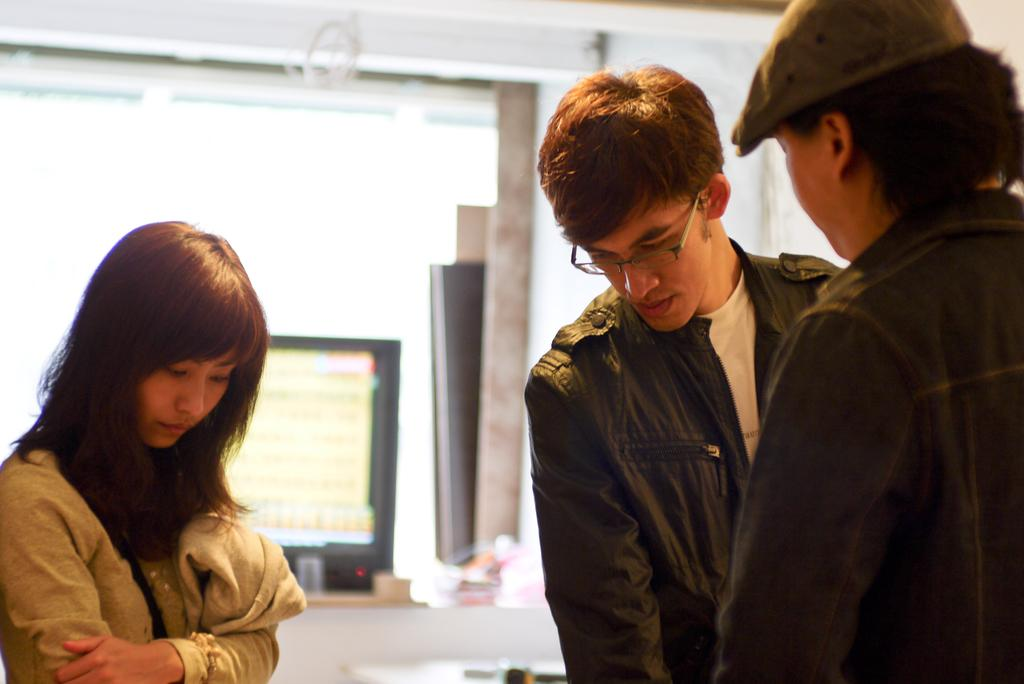What is located in the front of the image? There are persons standing in the front of the image. What can be seen in the background of the image? There is a screen and a wall in the background of the image. What type of ray can be seen swimming near the seashore in the image? There is no seashore or ray present in the image; it features persons standing in the front and a screen and a wall in the background. 